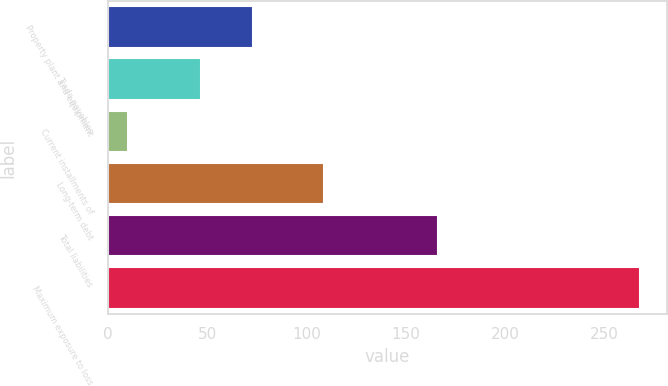<chart> <loc_0><loc_0><loc_500><loc_500><bar_chart><fcel>Property plant and equipment<fcel>Trade payables<fcel>Current installments of<fcel>Long-term debt<fcel>Total liabilities<fcel>Maximum exposure to loss<nl><fcel>73<fcel>47<fcel>10<fcel>109<fcel>166<fcel>268<nl></chart> 